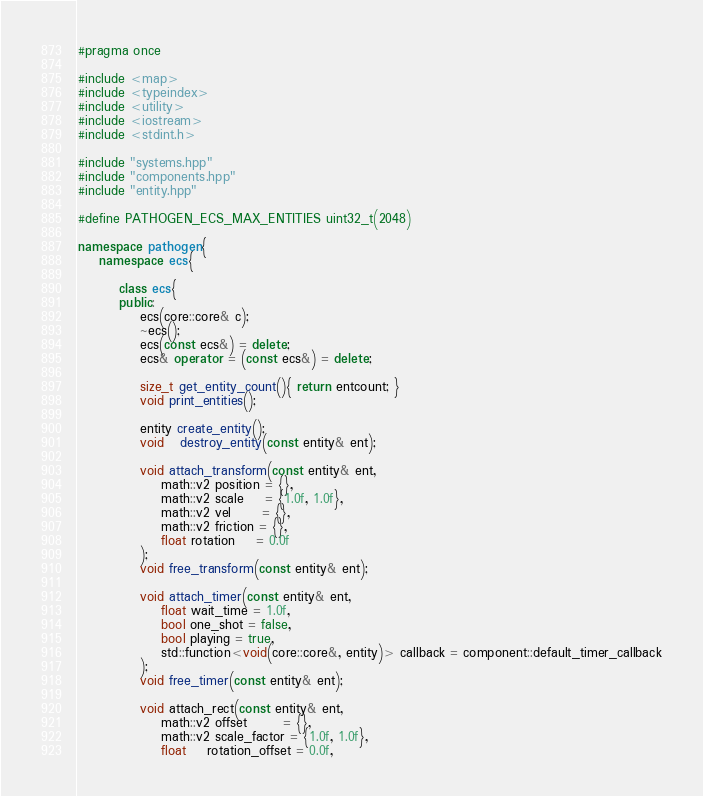<code> <loc_0><loc_0><loc_500><loc_500><_C++_>#pragma once

#include <map>
#include <typeindex>
#include <utility>
#include <iostream>
#include <stdint.h>

#include "systems.hpp"
#include "components.hpp"
#include "entity.hpp"

#define PATHOGEN_ECS_MAX_ENTITIES uint32_t(2048)

namespace pathogen{
    namespace ecs{
        
        class ecs{
        public:
            ecs(core::core& c);
            ~ecs();
            ecs(const ecs&) = delete;
            ecs& operator = (const ecs&) = delete;

            size_t get_entity_count(){ return entcount; }
            void print_entities();

            entity create_entity();
            void   destroy_entity(const entity& ent);

            void attach_transform(const entity& ent,
                math::v2 position = {},
                math::v2 scale    = {1.0f, 1.0f},
                math::v2 vel      = {},
                math::v2 friction = {},
                float rotation    = 0.0f
            );
            void free_transform(const entity& ent);

            void attach_timer(const entity& ent,
                float wait_time = 1.0f,
                bool one_shot = false,
                bool playing = true,
                std::function<void(core::core&, entity)> callback = component::default_timer_callback
            );
            void free_timer(const entity& ent);

            void attach_rect(const entity& ent,
                math::v2 offset       = {},
                math::v2 scale_factor = {1.0f, 1.0f},
                float    rotation_offset = 0.0f,</code> 